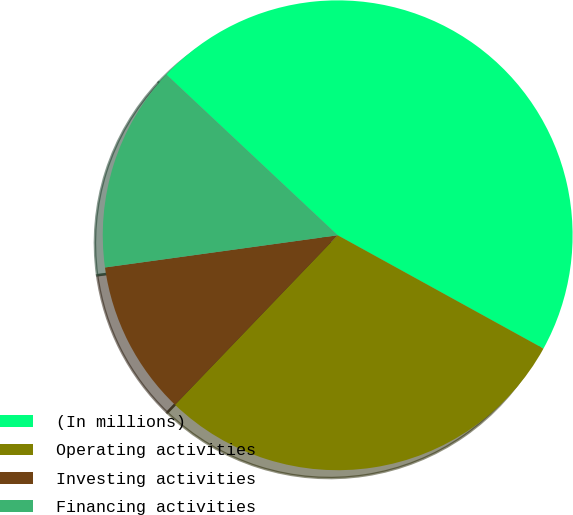Convert chart. <chart><loc_0><loc_0><loc_500><loc_500><pie_chart><fcel>(In millions)<fcel>Operating activities<fcel>Investing activities<fcel>Financing activities<nl><fcel>46.02%<fcel>29.16%<fcel>10.64%<fcel>14.18%<nl></chart> 